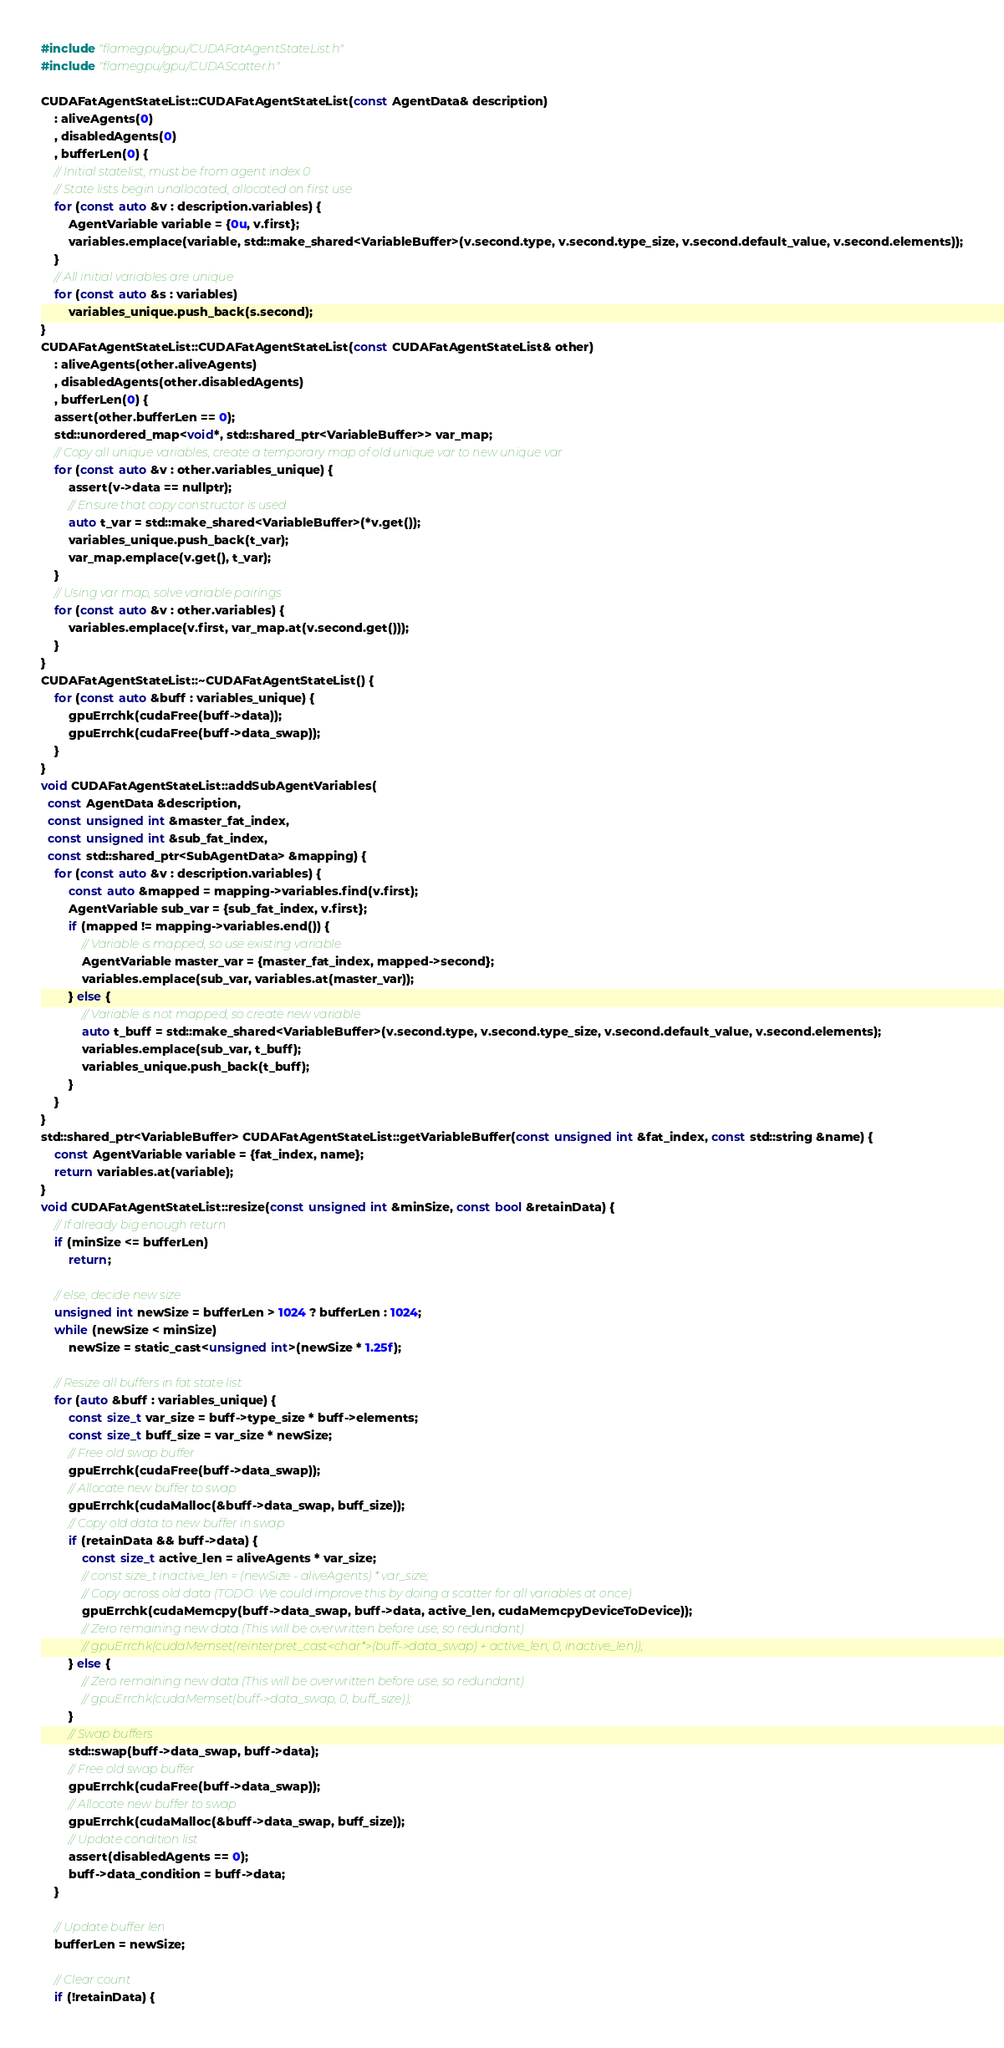<code> <loc_0><loc_0><loc_500><loc_500><_Cuda_>#include "flamegpu/gpu/CUDAFatAgentStateList.h"
#include "flamegpu/gpu/CUDAScatter.h"

CUDAFatAgentStateList::CUDAFatAgentStateList(const AgentData& description)
    : aliveAgents(0)
    , disabledAgents(0)
    , bufferLen(0) {
    // Initial statelist, must be from agent index 0
    // State lists begin unallocated, allocated on first use
    for (const auto &v : description.variables) {
        AgentVariable variable = {0u, v.first};
        variables.emplace(variable, std::make_shared<VariableBuffer>(v.second.type, v.second.type_size, v.second.default_value, v.second.elements));
    }
    // All initial variables are unique
    for (const auto &s : variables)
        variables_unique.push_back(s.second);
}
CUDAFatAgentStateList::CUDAFatAgentStateList(const CUDAFatAgentStateList& other)
    : aliveAgents(other.aliveAgents)
    , disabledAgents(other.disabledAgents)
    , bufferLen(0) {
    assert(other.bufferLen == 0);
    std::unordered_map<void*, std::shared_ptr<VariableBuffer>> var_map;
    // Copy all unique variables, create a temporary map of old unique var to new unique var
    for (const auto &v : other.variables_unique) {
        assert(v->data == nullptr);
        // Ensure that copy constructor is used
        auto t_var = std::make_shared<VariableBuffer>(*v.get());
        variables_unique.push_back(t_var);
        var_map.emplace(v.get(), t_var);
    }
    // Using var map, solve variable pairings
    for (const auto &v : other.variables) {
        variables.emplace(v.first, var_map.at(v.second.get()));
    }
}
CUDAFatAgentStateList::~CUDAFatAgentStateList() {
    for (const auto &buff : variables_unique) {
        gpuErrchk(cudaFree(buff->data));
        gpuErrchk(cudaFree(buff->data_swap));
    }
}
void CUDAFatAgentStateList::addSubAgentVariables(
  const AgentData &description,
  const unsigned int &master_fat_index,
  const unsigned int &sub_fat_index,
  const std::shared_ptr<SubAgentData> &mapping) {
    for (const auto &v : description.variables) {
        const auto &mapped = mapping->variables.find(v.first);
        AgentVariable sub_var = {sub_fat_index, v.first};
        if (mapped != mapping->variables.end()) {
            // Variable is mapped, so use existing variable
            AgentVariable master_var = {master_fat_index, mapped->second};
            variables.emplace(sub_var, variables.at(master_var));
        } else {
            // Variable is not mapped, so create new variable
            auto t_buff = std::make_shared<VariableBuffer>(v.second.type, v.second.type_size, v.second.default_value, v.second.elements);
            variables.emplace(sub_var, t_buff);
            variables_unique.push_back(t_buff);
        }
    }
}
std::shared_ptr<VariableBuffer> CUDAFatAgentStateList::getVariableBuffer(const unsigned int &fat_index, const std::string &name) {
    const AgentVariable variable = {fat_index, name};
    return variables.at(variable);
}
void CUDAFatAgentStateList::resize(const unsigned int &minSize, const bool &retainData) {
    // If already big enough return
    if (minSize <= bufferLen)
        return;

    // else, decide new size
    unsigned int newSize = bufferLen > 1024 ? bufferLen : 1024;
    while (newSize < minSize)
        newSize = static_cast<unsigned int>(newSize * 1.25f);

    // Resize all buffers in fat state list
    for (auto &buff : variables_unique) {
        const size_t var_size = buff->type_size * buff->elements;
        const size_t buff_size = var_size * newSize;
        // Free old swap buffer
        gpuErrchk(cudaFree(buff->data_swap));
        // Allocate new buffer to swap
        gpuErrchk(cudaMalloc(&buff->data_swap, buff_size));
        // Copy old data to new buffer in swap
        if (retainData && buff->data) {
            const size_t active_len = aliveAgents * var_size;
            // const size_t inactive_len = (newSize - aliveAgents) * var_size;
            // Copy across old data (TODO: We could improve this by doing a scatter for all variables at once)
            gpuErrchk(cudaMemcpy(buff->data_swap, buff->data, active_len, cudaMemcpyDeviceToDevice));
            // Zero remaining new data (This will be overwritten before use, so redundant)
            // gpuErrchk(cudaMemset(reinterpret_cast<char*>(buff->data_swap) + active_len, 0, inactive_len));
        } else {
            // Zero remaining new data (This will be overwritten before use, so redundant)
            // gpuErrchk(cudaMemset(buff->data_swap, 0, buff_size));
        }
        // Swap buffers
        std::swap(buff->data_swap, buff->data);
        // Free old swap buffer
        gpuErrchk(cudaFree(buff->data_swap));
        // Allocate new buffer to swap
        gpuErrchk(cudaMalloc(&buff->data_swap, buff_size));
        // Update condition list
        assert(disabledAgents == 0);
        buff->data_condition = buff->data;
    }

    // Update buffer len
    bufferLen = newSize;

    // Clear count
    if (!retainData) {</code> 